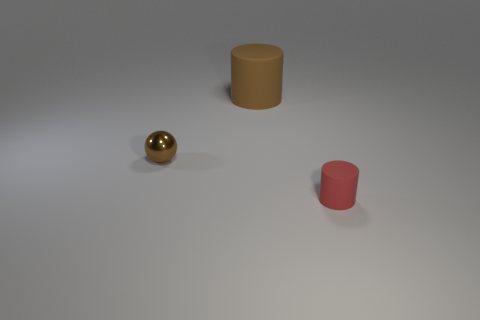Add 1 brown rubber objects. How many objects exist? 4 Subtract all cylinders. How many objects are left? 1 Add 3 cubes. How many cubes exist? 3 Subtract 0 gray blocks. How many objects are left? 3 Subtract all cyan cylinders. Subtract all purple spheres. How many cylinders are left? 2 Subtract all large purple rubber cubes. Subtract all large brown rubber cylinders. How many objects are left? 2 Add 1 big brown matte objects. How many big brown matte objects are left? 2 